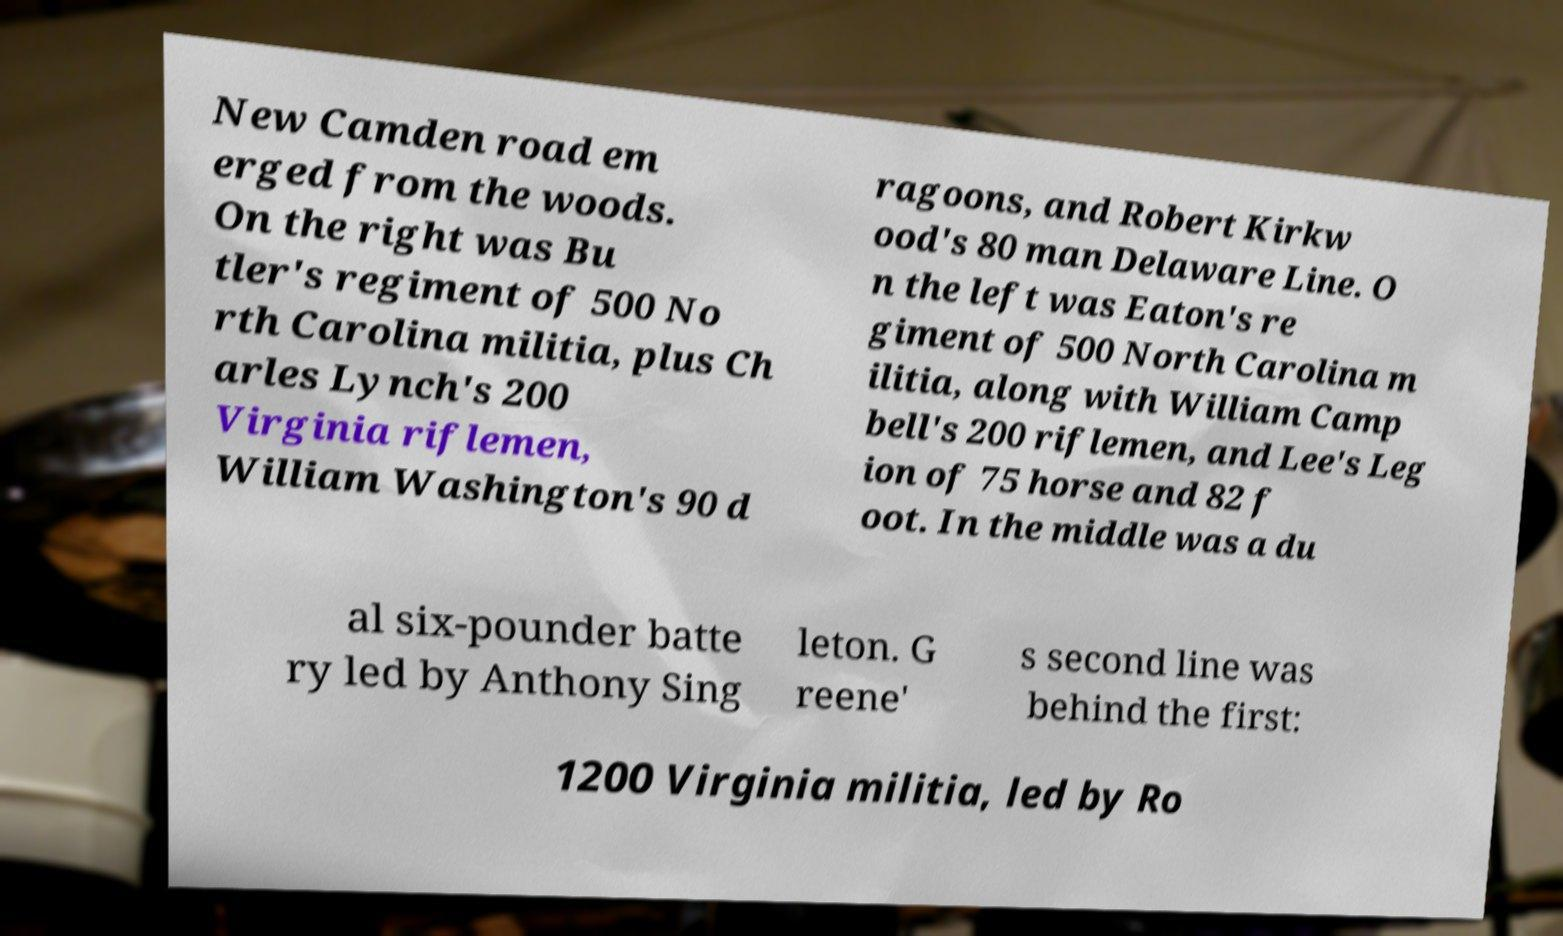There's text embedded in this image that I need extracted. Can you transcribe it verbatim? New Camden road em erged from the woods. On the right was Bu tler's regiment of 500 No rth Carolina militia, plus Ch arles Lynch's 200 Virginia riflemen, William Washington's 90 d ragoons, and Robert Kirkw ood's 80 man Delaware Line. O n the left was Eaton's re giment of 500 North Carolina m ilitia, along with William Camp bell's 200 riflemen, and Lee's Leg ion of 75 horse and 82 f oot. In the middle was a du al six-pounder batte ry led by Anthony Sing leton. G reene' s second line was behind the first: 1200 Virginia militia, led by Ro 